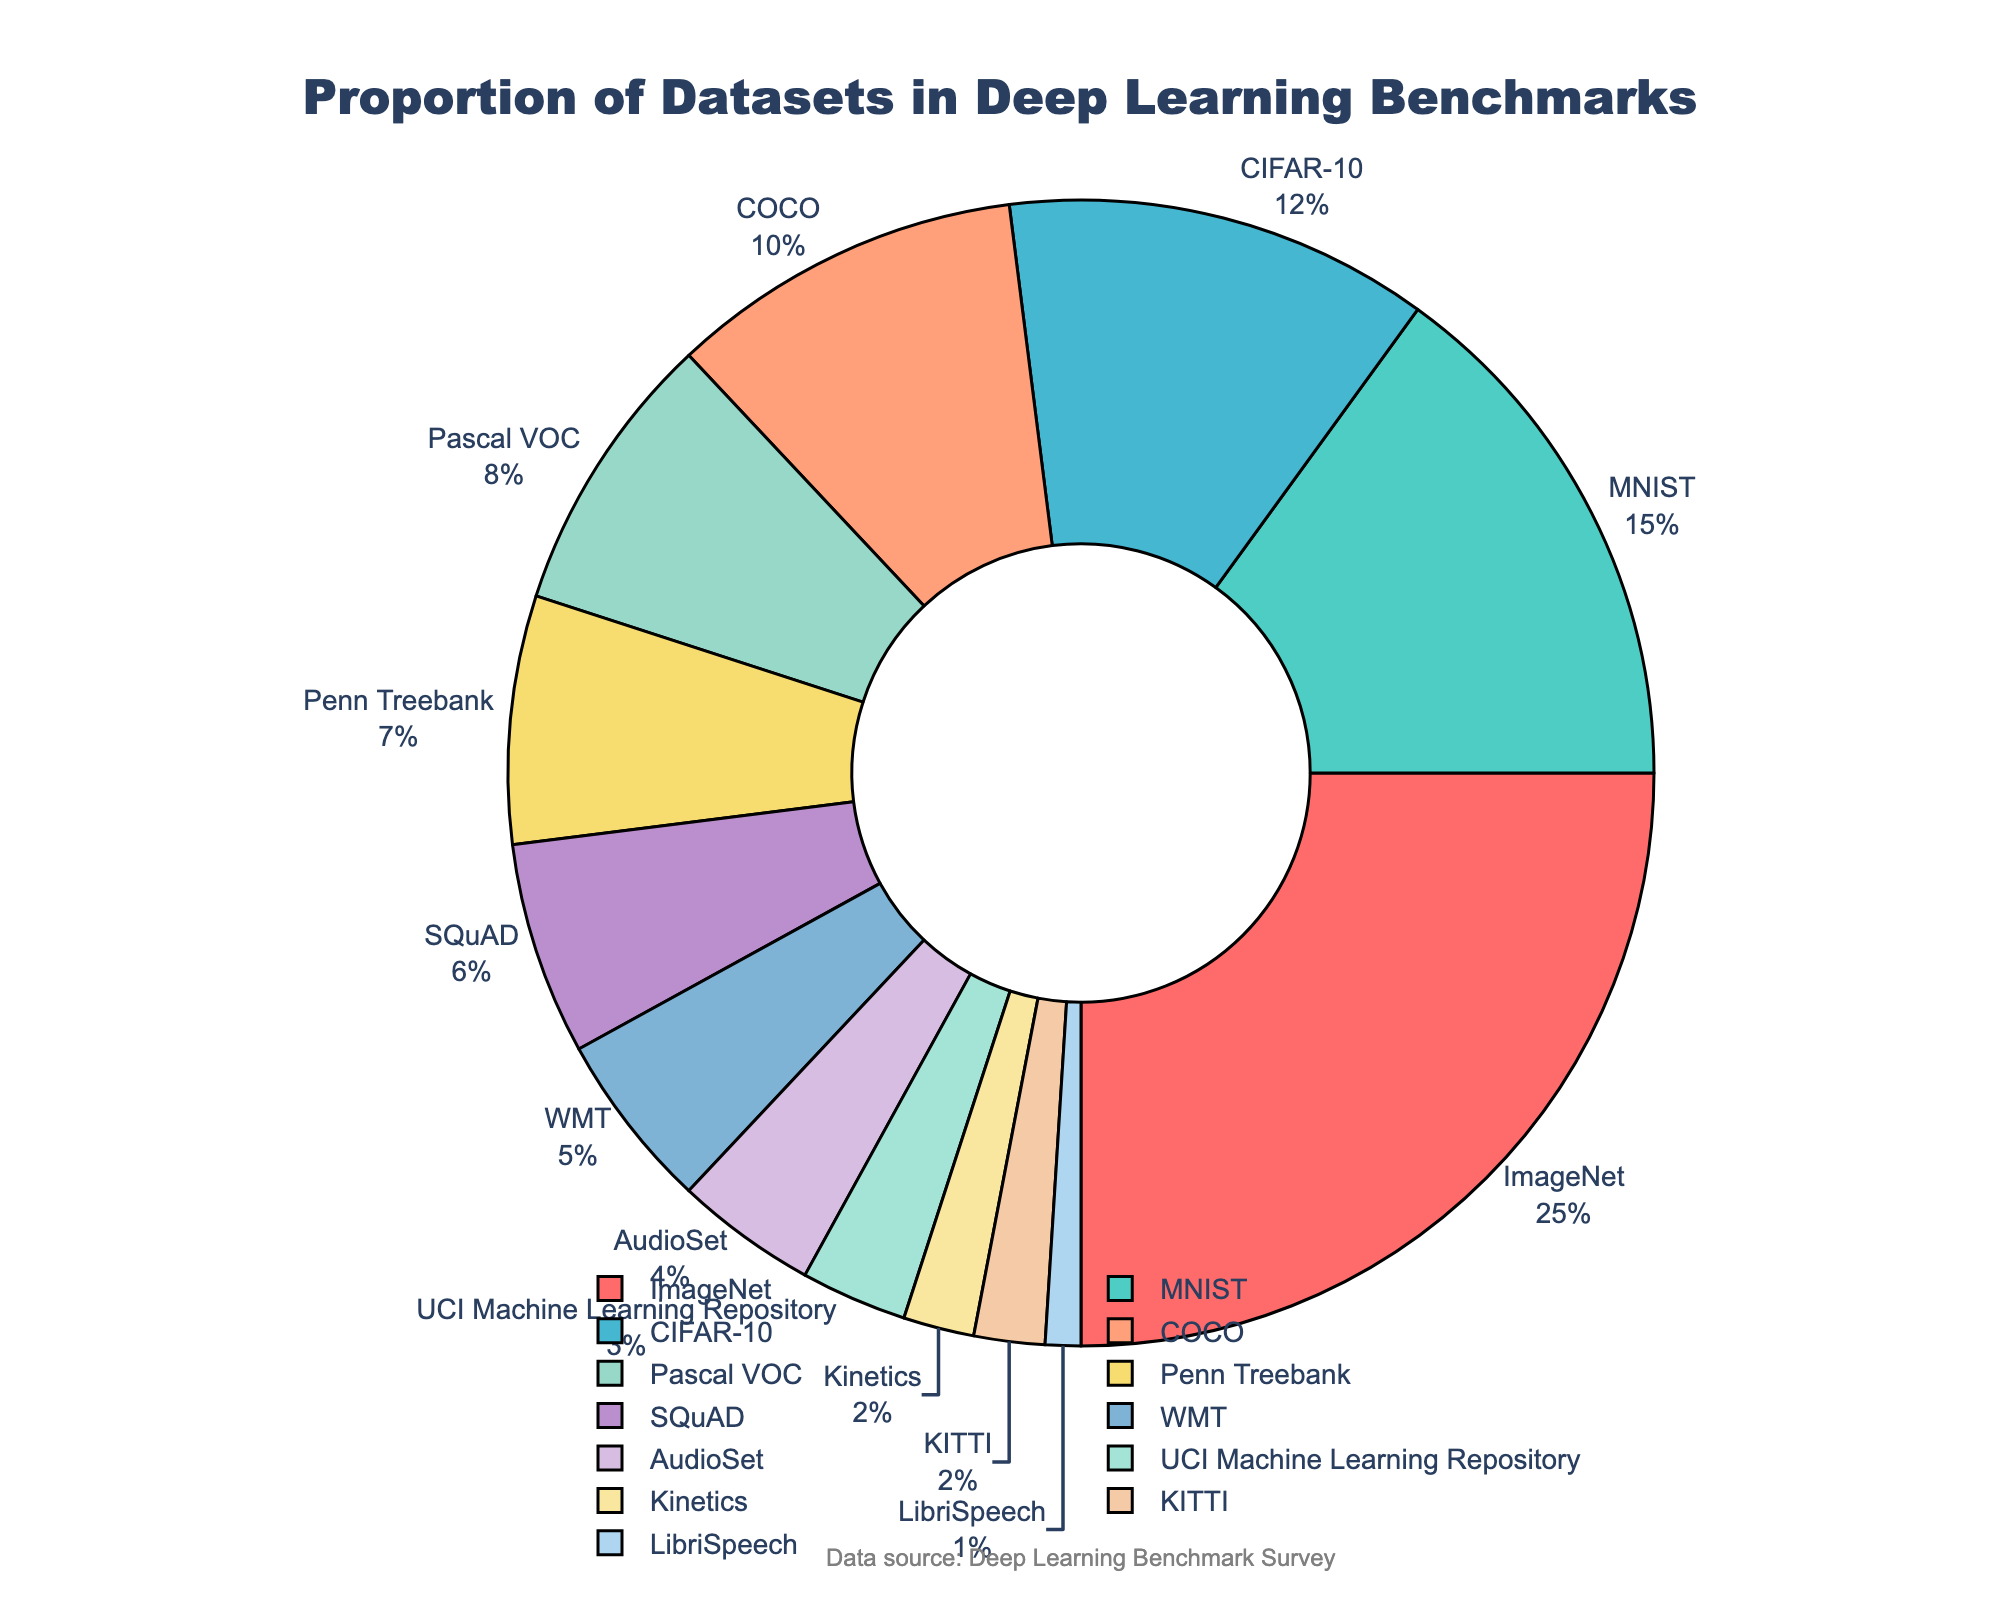what is the sum of the percentages for the top three dataset types? The top three dataset types by percentage are ImageNet, MNIST, and CIFAR-10 with percentages of 25, 15, and 12 respectively. Summing these percentages gives 25 + 15 + 12 = 52
Answer: 52 Which dataset type has the smallest percentage? The dataset type with the smallest percentage is LibriSpeech which has a percentage of 1%
Answer: LibriSpeech Are there more datasets with a percentage less than 5 or greater than 5? There are four datasets with a percentage less than 5 (AudioSet, UCI Machine Learning Repository, Kinetics, KITTI, LibriSpeech) and nine datasets with a percentage greater than 5 (ImageNet, MNIST, CIFAR-10, COCO, Pascal VOC, Penn Treebank, SQuAD, WMT). Thus, there are more datasets with percentages greater than 5
Answer: Greater than 5 How does the proportion of ImageNet compare to the sum of COCO and Kinetics? ImageNet has a percentage of 25%. COCO has 10% and Kinetics has 2%. Summing COCO and Kinetics gives 10 + 2 = 12%. Thus, ImageNet's proportion (25%) is greater than the sum of COCO and Kinetics (12%)
Answer: ImageNet is greater Which color corresponds to Pascal VOC and how far is it positioned relative to the start of the pie chart? Pascal VOC is represented by the fifth largest sector, which is colored violet. It is positioned fifth from the top right side as the chart starts from 90 degrees
Answer: Violet, fifth position from top right What is the difference in percentage between ImageNet and CIFAR-10? ImageNet has a percentage of 25% and CIFAR-10 has 12%. The difference between them is 25 - 12 = 13
Answer: 13 